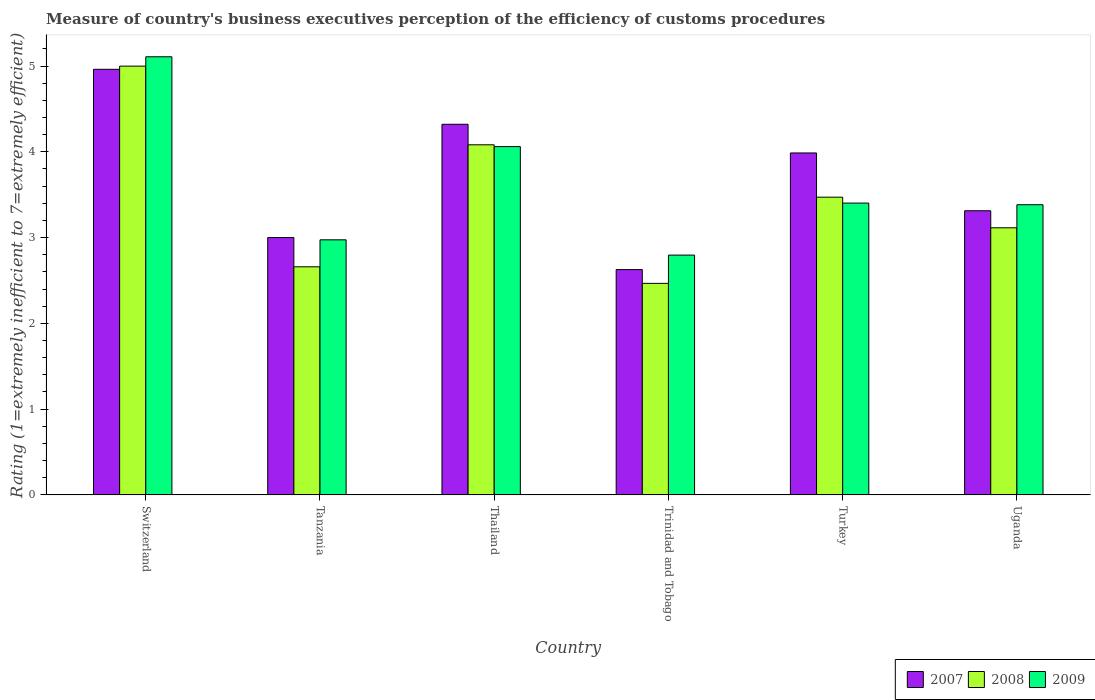Are the number of bars per tick equal to the number of legend labels?
Your response must be concise. Yes. How many bars are there on the 2nd tick from the left?
Provide a succinct answer. 3. How many bars are there on the 2nd tick from the right?
Keep it short and to the point. 3. What is the label of the 6th group of bars from the left?
Offer a very short reply. Uganda. In how many cases, is the number of bars for a given country not equal to the number of legend labels?
Provide a short and direct response. 0. What is the rating of the efficiency of customs procedure in 2009 in Turkey?
Offer a terse response. 3.4. Across all countries, what is the maximum rating of the efficiency of customs procedure in 2009?
Offer a terse response. 5.11. Across all countries, what is the minimum rating of the efficiency of customs procedure in 2008?
Make the answer very short. 2.47. In which country was the rating of the efficiency of customs procedure in 2007 maximum?
Your answer should be very brief. Switzerland. In which country was the rating of the efficiency of customs procedure in 2007 minimum?
Ensure brevity in your answer.  Trinidad and Tobago. What is the total rating of the efficiency of customs procedure in 2009 in the graph?
Ensure brevity in your answer.  21.72. What is the difference between the rating of the efficiency of customs procedure in 2009 in Tanzania and that in Trinidad and Tobago?
Offer a very short reply. 0.18. What is the difference between the rating of the efficiency of customs procedure in 2007 in Trinidad and Tobago and the rating of the efficiency of customs procedure in 2008 in Switzerland?
Your answer should be very brief. -2.37. What is the average rating of the efficiency of customs procedure in 2008 per country?
Your answer should be compact. 3.46. What is the difference between the rating of the efficiency of customs procedure of/in 2009 and rating of the efficiency of customs procedure of/in 2008 in Trinidad and Tobago?
Offer a very short reply. 0.33. In how many countries, is the rating of the efficiency of customs procedure in 2007 greater than 4.6?
Ensure brevity in your answer.  1. What is the ratio of the rating of the efficiency of customs procedure in 2007 in Trinidad and Tobago to that in Uganda?
Give a very brief answer. 0.79. Is the rating of the efficiency of customs procedure in 2007 in Switzerland less than that in Turkey?
Provide a short and direct response. No. Is the difference between the rating of the efficiency of customs procedure in 2009 in Tanzania and Turkey greater than the difference between the rating of the efficiency of customs procedure in 2008 in Tanzania and Turkey?
Provide a short and direct response. Yes. What is the difference between the highest and the second highest rating of the efficiency of customs procedure in 2008?
Your response must be concise. -1.53. What is the difference between the highest and the lowest rating of the efficiency of customs procedure in 2008?
Provide a succinct answer. 2.53. What does the 3rd bar from the left in Switzerland represents?
Ensure brevity in your answer.  2009. Is it the case that in every country, the sum of the rating of the efficiency of customs procedure in 2008 and rating of the efficiency of customs procedure in 2007 is greater than the rating of the efficiency of customs procedure in 2009?
Offer a terse response. Yes. How many bars are there?
Your answer should be very brief. 18. Are all the bars in the graph horizontal?
Make the answer very short. No. Does the graph contain any zero values?
Provide a short and direct response. No. Does the graph contain grids?
Provide a short and direct response. No. How many legend labels are there?
Make the answer very short. 3. What is the title of the graph?
Your answer should be compact. Measure of country's business executives perception of the efficiency of customs procedures. Does "2013" appear as one of the legend labels in the graph?
Make the answer very short. No. What is the label or title of the X-axis?
Provide a short and direct response. Country. What is the label or title of the Y-axis?
Provide a succinct answer. Rating (1=extremely inefficient to 7=extremely efficient). What is the Rating (1=extremely inefficient to 7=extremely efficient) in 2007 in Switzerland?
Offer a terse response. 4.96. What is the Rating (1=extremely inefficient to 7=extremely efficient) of 2008 in Switzerland?
Offer a terse response. 5. What is the Rating (1=extremely inefficient to 7=extremely efficient) in 2009 in Switzerland?
Offer a very short reply. 5.11. What is the Rating (1=extremely inefficient to 7=extremely efficient) in 2007 in Tanzania?
Provide a short and direct response. 3. What is the Rating (1=extremely inefficient to 7=extremely efficient) of 2008 in Tanzania?
Provide a succinct answer. 2.66. What is the Rating (1=extremely inefficient to 7=extremely efficient) in 2009 in Tanzania?
Make the answer very short. 2.97. What is the Rating (1=extremely inefficient to 7=extremely efficient) of 2007 in Thailand?
Provide a short and direct response. 4.32. What is the Rating (1=extremely inefficient to 7=extremely efficient) of 2008 in Thailand?
Ensure brevity in your answer.  4.08. What is the Rating (1=extremely inefficient to 7=extremely efficient) of 2009 in Thailand?
Ensure brevity in your answer.  4.06. What is the Rating (1=extremely inefficient to 7=extremely efficient) of 2007 in Trinidad and Tobago?
Your response must be concise. 2.63. What is the Rating (1=extremely inefficient to 7=extremely efficient) in 2008 in Trinidad and Tobago?
Make the answer very short. 2.47. What is the Rating (1=extremely inefficient to 7=extremely efficient) in 2009 in Trinidad and Tobago?
Offer a terse response. 2.8. What is the Rating (1=extremely inefficient to 7=extremely efficient) of 2007 in Turkey?
Give a very brief answer. 3.99. What is the Rating (1=extremely inefficient to 7=extremely efficient) in 2008 in Turkey?
Ensure brevity in your answer.  3.47. What is the Rating (1=extremely inefficient to 7=extremely efficient) in 2009 in Turkey?
Your answer should be compact. 3.4. What is the Rating (1=extremely inefficient to 7=extremely efficient) in 2007 in Uganda?
Provide a short and direct response. 3.31. What is the Rating (1=extremely inefficient to 7=extremely efficient) of 2008 in Uganda?
Provide a succinct answer. 3.11. What is the Rating (1=extremely inefficient to 7=extremely efficient) of 2009 in Uganda?
Your answer should be compact. 3.38. Across all countries, what is the maximum Rating (1=extremely inefficient to 7=extremely efficient) of 2007?
Offer a very short reply. 4.96. Across all countries, what is the maximum Rating (1=extremely inefficient to 7=extremely efficient) of 2008?
Provide a short and direct response. 5. Across all countries, what is the maximum Rating (1=extremely inefficient to 7=extremely efficient) of 2009?
Offer a very short reply. 5.11. Across all countries, what is the minimum Rating (1=extremely inefficient to 7=extremely efficient) of 2007?
Offer a terse response. 2.63. Across all countries, what is the minimum Rating (1=extremely inefficient to 7=extremely efficient) of 2008?
Offer a terse response. 2.47. Across all countries, what is the minimum Rating (1=extremely inefficient to 7=extremely efficient) of 2009?
Keep it short and to the point. 2.8. What is the total Rating (1=extremely inefficient to 7=extremely efficient) in 2007 in the graph?
Offer a terse response. 22.21. What is the total Rating (1=extremely inefficient to 7=extremely efficient) of 2008 in the graph?
Make the answer very short. 20.79. What is the total Rating (1=extremely inefficient to 7=extremely efficient) of 2009 in the graph?
Offer a terse response. 21.72. What is the difference between the Rating (1=extremely inefficient to 7=extremely efficient) of 2007 in Switzerland and that in Tanzania?
Offer a terse response. 1.96. What is the difference between the Rating (1=extremely inefficient to 7=extremely efficient) in 2008 in Switzerland and that in Tanzania?
Keep it short and to the point. 2.34. What is the difference between the Rating (1=extremely inefficient to 7=extremely efficient) in 2009 in Switzerland and that in Tanzania?
Provide a succinct answer. 2.13. What is the difference between the Rating (1=extremely inefficient to 7=extremely efficient) in 2007 in Switzerland and that in Thailand?
Give a very brief answer. 0.64. What is the difference between the Rating (1=extremely inefficient to 7=extremely efficient) of 2008 in Switzerland and that in Thailand?
Offer a very short reply. 0.92. What is the difference between the Rating (1=extremely inefficient to 7=extremely efficient) in 2009 in Switzerland and that in Thailand?
Offer a very short reply. 1.05. What is the difference between the Rating (1=extremely inefficient to 7=extremely efficient) in 2007 in Switzerland and that in Trinidad and Tobago?
Offer a terse response. 2.33. What is the difference between the Rating (1=extremely inefficient to 7=extremely efficient) of 2008 in Switzerland and that in Trinidad and Tobago?
Give a very brief answer. 2.53. What is the difference between the Rating (1=extremely inefficient to 7=extremely efficient) of 2009 in Switzerland and that in Trinidad and Tobago?
Offer a terse response. 2.31. What is the difference between the Rating (1=extremely inefficient to 7=extremely efficient) in 2007 in Switzerland and that in Turkey?
Provide a succinct answer. 0.98. What is the difference between the Rating (1=extremely inefficient to 7=extremely efficient) in 2008 in Switzerland and that in Turkey?
Offer a very short reply. 1.53. What is the difference between the Rating (1=extremely inefficient to 7=extremely efficient) of 2009 in Switzerland and that in Turkey?
Give a very brief answer. 1.71. What is the difference between the Rating (1=extremely inefficient to 7=extremely efficient) of 2007 in Switzerland and that in Uganda?
Offer a terse response. 1.65. What is the difference between the Rating (1=extremely inefficient to 7=extremely efficient) in 2008 in Switzerland and that in Uganda?
Your response must be concise. 1.88. What is the difference between the Rating (1=extremely inefficient to 7=extremely efficient) in 2009 in Switzerland and that in Uganda?
Your response must be concise. 1.72. What is the difference between the Rating (1=extremely inefficient to 7=extremely efficient) in 2007 in Tanzania and that in Thailand?
Offer a very short reply. -1.32. What is the difference between the Rating (1=extremely inefficient to 7=extremely efficient) in 2008 in Tanzania and that in Thailand?
Offer a very short reply. -1.42. What is the difference between the Rating (1=extremely inefficient to 7=extremely efficient) of 2009 in Tanzania and that in Thailand?
Your answer should be compact. -1.09. What is the difference between the Rating (1=extremely inefficient to 7=extremely efficient) of 2007 in Tanzania and that in Trinidad and Tobago?
Ensure brevity in your answer.  0.37. What is the difference between the Rating (1=extremely inefficient to 7=extremely efficient) in 2008 in Tanzania and that in Trinidad and Tobago?
Your response must be concise. 0.19. What is the difference between the Rating (1=extremely inefficient to 7=extremely efficient) in 2009 in Tanzania and that in Trinidad and Tobago?
Provide a succinct answer. 0.18. What is the difference between the Rating (1=extremely inefficient to 7=extremely efficient) in 2007 in Tanzania and that in Turkey?
Offer a terse response. -0.99. What is the difference between the Rating (1=extremely inefficient to 7=extremely efficient) of 2008 in Tanzania and that in Turkey?
Offer a very short reply. -0.81. What is the difference between the Rating (1=extremely inefficient to 7=extremely efficient) in 2009 in Tanzania and that in Turkey?
Offer a terse response. -0.43. What is the difference between the Rating (1=extremely inefficient to 7=extremely efficient) in 2007 in Tanzania and that in Uganda?
Provide a succinct answer. -0.31. What is the difference between the Rating (1=extremely inefficient to 7=extremely efficient) in 2008 in Tanzania and that in Uganda?
Your answer should be compact. -0.45. What is the difference between the Rating (1=extremely inefficient to 7=extremely efficient) of 2009 in Tanzania and that in Uganda?
Keep it short and to the point. -0.41. What is the difference between the Rating (1=extremely inefficient to 7=extremely efficient) of 2007 in Thailand and that in Trinidad and Tobago?
Ensure brevity in your answer.  1.69. What is the difference between the Rating (1=extremely inefficient to 7=extremely efficient) of 2008 in Thailand and that in Trinidad and Tobago?
Ensure brevity in your answer.  1.62. What is the difference between the Rating (1=extremely inefficient to 7=extremely efficient) of 2009 in Thailand and that in Trinidad and Tobago?
Offer a terse response. 1.26. What is the difference between the Rating (1=extremely inefficient to 7=extremely efficient) of 2007 in Thailand and that in Turkey?
Your answer should be very brief. 0.33. What is the difference between the Rating (1=extremely inefficient to 7=extremely efficient) in 2008 in Thailand and that in Turkey?
Ensure brevity in your answer.  0.61. What is the difference between the Rating (1=extremely inefficient to 7=extremely efficient) of 2009 in Thailand and that in Turkey?
Keep it short and to the point. 0.66. What is the difference between the Rating (1=extremely inefficient to 7=extremely efficient) of 2007 in Thailand and that in Uganda?
Your answer should be compact. 1.01. What is the difference between the Rating (1=extremely inefficient to 7=extremely efficient) of 2008 in Thailand and that in Uganda?
Keep it short and to the point. 0.97. What is the difference between the Rating (1=extremely inefficient to 7=extremely efficient) in 2009 in Thailand and that in Uganda?
Keep it short and to the point. 0.68. What is the difference between the Rating (1=extremely inefficient to 7=extremely efficient) of 2007 in Trinidad and Tobago and that in Turkey?
Offer a terse response. -1.36. What is the difference between the Rating (1=extremely inefficient to 7=extremely efficient) of 2008 in Trinidad and Tobago and that in Turkey?
Give a very brief answer. -1. What is the difference between the Rating (1=extremely inefficient to 7=extremely efficient) in 2009 in Trinidad and Tobago and that in Turkey?
Your response must be concise. -0.61. What is the difference between the Rating (1=extremely inefficient to 7=extremely efficient) of 2007 in Trinidad and Tobago and that in Uganda?
Your answer should be compact. -0.69. What is the difference between the Rating (1=extremely inefficient to 7=extremely efficient) in 2008 in Trinidad and Tobago and that in Uganda?
Keep it short and to the point. -0.65. What is the difference between the Rating (1=extremely inefficient to 7=extremely efficient) of 2009 in Trinidad and Tobago and that in Uganda?
Offer a terse response. -0.59. What is the difference between the Rating (1=extremely inefficient to 7=extremely efficient) of 2007 in Turkey and that in Uganda?
Offer a terse response. 0.67. What is the difference between the Rating (1=extremely inefficient to 7=extremely efficient) in 2008 in Turkey and that in Uganda?
Give a very brief answer. 0.36. What is the difference between the Rating (1=extremely inefficient to 7=extremely efficient) of 2009 in Turkey and that in Uganda?
Your response must be concise. 0.02. What is the difference between the Rating (1=extremely inefficient to 7=extremely efficient) of 2007 in Switzerland and the Rating (1=extremely inefficient to 7=extremely efficient) of 2008 in Tanzania?
Your response must be concise. 2.3. What is the difference between the Rating (1=extremely inefficient to 7=extremely efficient) in 2007 in Switzerland and the Rating (1=extremely inefficient to 7=extremely efficient) in 2009 in Tanzania?
Keep it short and to the point. 1.99. What is the difference between the Rating (1=extremely inefficient to 7=extremely efficient) of 2008 in Switzerland and the Rating (1=extremely inefficient to 7=extremely efficient) of 2009 in Tanzania?
Your answer should be very brief. 2.02. What is the difference between the Rating (1=extremely inefficient to 7=extremely efficient) of 2007 in Switzerland and the Rating (1=extremely inefficient to 7=extremely efficient) of 2008 in Thailand?
Your response must be concise. 0.88. What is the difference between the Rating (1=extremely inefficient to 7=extremely efficient) in 2007 in Switzerland and the Rating (1=extremely inefficient to 7=extremely efficient) in 2009 in Thailand?
Provide a succinct answer. 0.9. What is the difference between the Rating (1=extremely inefficient to 7=extremely efficient) in 2008 in Switzerland and the Rating (1=extremely inefficient to 7=extremely efficient) in 2009 in Thailand?
Your answer should be very brief. 0.94. What is the difference between the Rating (1=extremely inefficient to 7=extremely efficient) in 2007 in Switzerland and the Rating (1=extremely inefficient to 7=extremely efficient) in 2008 in Trinidad and Tobago?
Ensure brevity in your answer.  2.5. What is the difference between the Rating (1=extremely inefficient to 7=extremely efficient) in 2007 in Switzerland and the Rating (1=extremely inefficient to 7=extremely efficient) in 2009 in Trinidad and Tobago?
Your answer should be very brief. 2.17. What is the difference between the Rating (1=extremely inefficient to 7=extremely efficient) of 2008 in Switzerland and the Rating (1=extremely inefficient to 7=extremely efficient) of 2009 in Trinidad and Tobago?
Provide a short and direct response. 2.2. What is the difference between the Rating (1=extremely inefficient to 7=extremely efficient) of 2007 in Switzerland and the Rating (1=extremely inefficient to 7=extremely efficient) of 2008 in Turkey?
Provide a succinct answer. 1.49. What is the difference between the Rating (1=extremely inefficient to 7=extremely efficient) of 2007 in Switzerland and the Rating (1=extremely inefficient to 7=extremely efficient) of 2009 in Turkey?
Provide a short and direct response. 1.56. What is the difference between the Rating (1=extremely inefficient to 7=extremely efficient) of 2008 in Switzerland and the Rating (1=extremely inefficient to 7=extremely efficient) of 2009 in Turkey?
Offer a very short reply. 1.6. What is the difference between the Rating (1=extremely inefficient to 7=extremely efficient) of 2007 in Switzerland and the Rating (1=extremely inefficient to 7=extremely efficient) of 2008 in Uganda?
Your answer should be compact. 1.85. What is the difference between the Rating (1=extremely inefficient to 7=extremely efficient) in 2007 in Switzerland and the Rating (1=extremely inefficient to 7=extremely efficient) in 2009 in Uganda?
Make the answer very short. 1.58. What is the difference between the Rating (1=extremely inefficient to 7=extremely efficient) of 2008 in Switzerland and the Rating (1=extremely inefficient to 7=extremely efficient) of 2009 in Uganda?
Give a very brief answer. 1.62. What is the difference between the Rating (1=extremely inefficient to 7=extremely efficient) of 2007 in Tanzania and the Rating (1=extremely inefficient to 7=extremely efficient) of 2008 in Thailand?
Keep it short and to the point. -1.08. What is the difference between the Rating (1=extremely inefficient to 7=extremely efficient) in 2007 in Tanzania and the Rating (1=extremely inefficient to 7=extremely efficient) in 2009 in Thailand?
Your answer should be very brief. -1.06. What is the difference between the Rating (1=extremely inefficient to 7=extremely efficient) of 2008 in Tanzania and the Rating (1=extremely inefficient to 7=extremely efficient) of 2009 in Thailand?
Offer a very short reply. -1.4. What is the difference between the Rating (1=extremely inefficient to 7=extremely efficient) of 2007 in Tanzania and the Rating (1=extremely inefficient to 7=extremely efficient) of 2008 in Trinidad and Tobago?
Give a very brief answer. 0.53. What is the difference between the Rating (1=extremely inefficient to 7=extremely efficient) in 2007 in Tanzania and the Rating (1=extremely inefficient to 7=extremely efficient) in 2009 in Trinidad and Tobago?
Keep it short and to the point. 0.2. What is the difference between the Rating (1=extremely inefficient to 7=extremely efficient) of 2008 in Tanzania and the Rating (1=extremely inefficient to 7=extremely efficient) of 2009 in Trinidad and Tobago?
Your response must be concise. -0.14. What is the difference between the Rating (1=extremely inefficient to 7=extremely efficient) in 2007 in Tanzania and the Rating (1=extremely inefficient to 7=extremely efficient) in 2008 in Turkey?
Provide a short and direct response. -0.47. What is the difference between the Rating (1=extremely inefficient to 7=extremely efficient) in 2007 in Tanzania and the Rating (1=extremely inefficient to 7=extremely efficient) in 2009 in Turkey?
Offer a very short reply. -0.4. What is the difference between the Rating (1=extremely inefficient to 7=extremely efficient) in 2008 in Tanzania and the Rating (1=extremely inefficient to 7=extremely efficient) in 2009 in Turkey?
Ensure brevity in your answer.  -0.74. What is the difference between the Rating (1=extremely inefficient to 7=extremely efficient) of 2007 in Tanzania and the Rating (1=extremely inefficient to 7=extremely efficient) of 2008 in Uganda?
Provide a succinct answer. -0.11. What is the difference between the Rating (1=extremely inefficient to 7=extremely efficient) of 2007 in Tanzania and the Rating (1=extremely inefficient to 7=extremely efficient) of 2009 in Uganda?
Make the answer very short. -0.38. What is the difference between the Rating (1=extremely inefficient to 7=extremely efficient) in 2008 in Tanzania and the Rating (1=extremely inefficient to 7=extremely efficient) in 2009 in Uganda?
Your response must be concise. -0.72. What is the difference between the Rating (1=extremely inefficient to 7=extremely efficient) in 2007 in Thailand and the Rating (1=extremely inefficient to 7=extremely efficient) in 2008 in Trinidad and Tobago?
Offer a very short reply. 1.85. What is the difference between the Rating (1=extremely inefficient to 7=extremely efficient) of 2007 in Thailand and the Rating (1=extremely inefficient to 7=extremely efficient) of 2009 in Trinidad and Tobago?
Your answer should be very brief. 1.53. What is the difference between the Rating (1=extremely inefficient to 7=extremely efficient) in 2008 in Thailand and the Rating (1=extremely inefficient to 7=extremely efficient) in 2009 in Trinidad and Tobago?
Provide a succinct answer. 1.29. What is the difference between the Rating (1=extremely inefficient to 7=extremely efficient) in 2007 in Thailand and the Rating (1=extremely inefficient to 7=extremely efficient) in 2008 in Turkey?
Your answer should be very brief. 0.85. What is the difference between the Rating (1=extremely inefficient to 7=extremely efficient) of 2007 in Thailand and the Rating (1=extremely inefficient to 7=extremely efficient) of 2009 in Turkey?
Your answer should be very brief. 0.92. What is the difference between the Rating (1=extremely inefficient to 7=extremely efficient) of 2008 in Thailand and the Rating (1=extremely inefficient to 7=extremely efficient) of 2009 in Turkey?
Provide a short and direct response. 0.68. What is the difference between the Rating (1=extremely inefficient to 7=extremely efficient) of 2007 in Thailand and the Rating (1=extremely inefficient to 7=extremely efficient) of 2008 in Uganda?
Your response must be concise. 1.21. What is the difference between the Rating (1=extremely inefficient to 7=extremely efficient) in 2007 in Thailand and the Rating (1=extremely inefficient to 7=extremely efficient) in 2009 in Uganda?
Offer a very short reply. 0.94. What is the difference between the Rating (1=extremely inefficient to 7=extremely efficient) of 2008 in Thailand and the Rating (1=extremely inefficient to 7=extremely efficient) of 2009 in Uganda?
Offer a very short reply. 0.7. What is the difference between the Rating (1=extremely inefficient to 7=extremely efficient) in 2007 in Trinidad and Tobago and the Rating (1=extremely inefficient to 7=extremely efficient) in 2008 in Turkey?
Provide a succinct answer. -0.84. What is the difference between the Rating (1=extremely inefficient to 7=extremely efficient) of 2007 in Trinidad and Tobago and the Rating (1=extremely inefficient to 7=extremely efficient) of 2009 in Turkey?
Provide a succinct answer. -0.78. What is the difference between the Rating (1=extremely inefficient to 7=extremely efficient) in 2008 in Trinidad and Tobago and the Rating (1=extremely inefficient to 7=extremely efficient) in 2009 in Turkey?
Keep it short and to the point. -0.94. What is the difference between the Rating (1=extremely inefficient to 7=extremely efficient) of 2007 in Trinidad and Tobago and the Rating (1=extremely inefficient to 7=extremely efficient) of 2008 in Uganda?
Give a very brief answer. -0.49. What is the difference between the Rating (1=extremely inefficient to 7=extremely efficient) in 2007 in Trinidad and Tobago and the Rating (1=extremely inefficient to 7=extremely efficient) in 2009 in Uganda?
Give a very brief answer. -0.76. What is the difference between the Rating (1=extremely inefficient to 7=extremely efficient) in 2008 in Trinidad and Tobago and the Rating (1=extremely inefficient to 7=extremely efficient) in 2009 in Uganda?
Offer a very short reply. -0.92. What is the difference between the Rating (1=extremely inefficient to 7=extremely efficient) in 2007 in Turkey and the Rating (1=extremely inefficient to 7=extremely efficient) in 2008 in Uganda?
Your answer should be compact. 0.87. What is the difference between the Rating (1=extremely inefficient to 7=extremely efficient) in 2007 in Turkey and the Rating (1=extremely inefficient to 7=extremely efficient) in 2009 in Uganda?
Provide a short and direct response. 0.6. What is the difference between the Rating (1=extremely inefficient to 7=extremely efficient) of 2008 in Turkey and the Rating (1=extremely inefficient to 7=extremely efficient) of 2009 in Uganda?
Offer a very short reply. 0.09. What is the average Rating (1=extremely inefficient to 7=extremely efficient) in 2007 per country?
Make the answer very short. 3.7. What is the average Rating (1=extremely inefficient to 7=extremely efficient) of 2008 per country?
Your response must be concise. 3.46. What is the average Rating (1=extremely inefficient to 7=extremely efficient) of 2009 per country?
Keep it short and to the point. 3.62. What is the difference between the Rating (1=extremely inefficient to 7=extremely efficient) in 2007 and Rating (1=extremely inefficient to 7=extremely efficient) in 2008 in Switzerland?
Your answer should be very brief. -0.04. What is the difference between the Rating (1=extremely inefficient to 7=extremely efficient) of 2007 and Rating (1=extremely inefficient to 7=extremely efficient) of 2009 in Switzerland?
Provide a short and direct response. -0.15. What is the difference between the Rating (1=extremely inefficient to 7=extremely efficient) in 2008 and Rating (1=extremely inefficient to 7=extremely efficient) in 2009 in Switzerland?
Provide a short and direct response. -0.11. What is the difference between the Rating (1=extremely inefficient to 7=extremely efficient) of 2007 and Rating (1=extremely inefficient to 7=extremely efficient) of 2008 in Tanzania?
Provide a succinct answer. 0.34. What is the difference between the Rating (1=extremely inefficient to 7=extremely efficient) in 2007 and Rating (1=extremely inefficient to 7=extremely efficient) in 2009 in Tanzania?
Your response must be concise. 0.03. What is the difference between the Rating (1=extremely inefficient to 7=extremely efficient) in 2008 and Rating (1=extremely inefficient to 7=extremely efficient) in 2009 in Tanzania?
Your response must be concise. -0.31. What is the difference between the Rating (1=extremely inefficient to 7=extremely efficient) in 2007 and Rating (1=extremely inefficient to 7=extremely efficient) in 2008 in Thailand?
Offer a terse response. 0.24. What is the difference between the Rating (1=extremely inefficient to 7=extremely efficient) of 2007 and Rating (1=extremely inefficient to 7=extremely efficient) of 2009 in Thailand?
Your answer should be very brief. 0.26. What is the difference between the Rating (1=extremely inefficient to 7=extremely efficient) of 2008 and Rating (1=extremely inefficient to 7=extremely efficient) of 2009 in Thailand?
Provide a succinct answer. 0.02. What is the difference between the Rating (1=extremely inefficient to 7=extremely efficient) of 2007 and Rating (1=extremely inefficient to 7=extremely efficient) of 2008 in Trinidad and Tobago?
Ensure brevity in your answer.  0.16. What is the difference between the Rating (1=extremely inefficient to 7=extremely efficient) of 2007 and Rating (1=extremely inefficient to 7=extremely efficient) of 2009 in Trinidad and Tobago?
Give a very brief answer. -0.17. What is the difference between the Rating (1=extremely inefficient to 7=extremely efficient) of 2008 and Rating (1=extremely inefficient to 7=extremely efficient) of 2009 in Trinidad and Tobago?
Provide a succinct answer. -0.33. What is the difference between the Rating (1=extremely inefficient to 7=extremely efficient) in 2007 and Rating (1=extremely inefficient to 7=extremely efficient) in 2008 in Turkey?
Your answer should be very brief. 0.52. What is the difference between the Rating (1=extremely inefficient to 7=extremely efficient) in 2007 and Rating (1=extremely inefficient to 7=extremely efficient) in 2009 in Turkey?
Provide a short and direct response. 0.58. What is the difference between the Rating (1=extremely inefficient to 7=extremely efficient) in 2008 and Rating (1=extremely inefficient to 7=extremely efficient) in 2009 in Turkey?
Provide a succinct answer. 0.07. What is the difference between the Rating (1=extremely inefficient to 7=extremely efficient) of 2007 and Rating (1=extremely inefficient to 7=extremely efficient) of 2008 in Uganda?
Ensure brevity in your answer.  0.2. What is the difference between the Rating (1=extremely inefficient to 7=extremely efficient) in 2007 and Rating (1=extremely inefficient to 7=extremely efficient) in 2009 in Uganda?
Make the answer very short. -0.07. What is the difference between the Rating (1=extremely inefficient to 7=extremely efficient) of 2008 and Rating (1=extremely inefficient to 7=extremely efficient) of 2009 in Uganda?
Your answer should be very brief. -0.27. What is the ratio of the Rating (1=extremely inefficient to 7=extremely efficient) of 2007 in Switzerland to that in Tanzania?
Your response must be concise. 1.65. What is the ratio of the Rating (1=extremely inefficient to 7=extremely efficient) in 2008 in Switzerland to that in Tanzania?
Your answer should be compact. 1.88. What is the ratio of the Rating (1=extremely inefficient to 7=extremely efficient) of 2009 in Switzerland to that in Tanzania?
Make the answer very short. 1.72. What is the ratio of the Rating (1=extremely inefficient to 7=extremely efficient) in 2007 in Switzerland to that in Thailand?
Offer a terse response. 1.15. What is the ratio of the Rating (1=extremely inefficient to 7=extremely efficient) in 2008 in Switzerland to that in Thailand?
Offer a terse response. 1.22. What is the ratio of the Rating (1=extremely inefficient to 7=extremely efficient) in 2009 in Switzerland to that in Thailand?
Ensure brevity in your answer.  1.26. What is the ratio of the Rating (1=extremely inefficient to 7=extremely efficient) of 2007 in Switzerland to that in Trinidad and Tobago?
Provide a short and direct response. 1.89. What is the ratio of the Rating (1=extremely inefficient to 7=extremely efficient) of 2008 in Switzerland to that in Trinidad and Tobago?
Provide a succinct answer. 2.03. What is the ratio of the Rating (1=extremely inefficient to 7=extremely efficient) in 2009 in Switzerland to that in Trinidad and Tobago?
Ensure brevity in your answer.  1.83. What is the ratio of the Rating (1=extremely inefficient to 7=extremely efficient) in 2007 in Switzerland to that in Turkey?
Make the answer very short. 1.24. What is the ratio of the Rating (1=extremely inefficient to 7=extremely efficient) of 2008 in Switzerland to that in Turkey?
Your answer should be compact. 1.44. What is the ratio of the Rating (1=extremely inefficient to 7=extremely efficient) of 2009 in Switzerland to that in Turkey?
Your answer should be very brief. 1.5. What is the ratio of the Rating (1=extremely inefficient to 7=extremely efficient) in 2007 in Switzerland to that in Uganda?
Offer a terse response. 1.5. What is the ratio of the Rating (1=extremely inefficient to 7=extremely efficient) of 2008 in Switzerland to that in Uganda?
Offer a terse response. 1.61. What is the ratio of the Rating (1=extremely inefficient to 7=extremely efficient) in 2009 in Switzerland to that in Uganda?
Your response must be concise. 1.51. What is the ratio of the Rating (1=extremely inefficient to 7=extremely efficient) of 2007 in Tanzania to that in Thailand?
Keep it short and to the point. 0.69. What is the ratio of the Rating (1=extremely inefficient to 7=extremely efficient) in 2008 in Tanzania to that in Thailand?
Give a very brief answer. 0.65. What is the ratio of the Rating (1=extremely inefficient to 7=extremely efficient) of 2009 in Tanzania to that in Thailand?
Provide a succinct answer. 0.73. What is the ratio of the Rating (1=extremely inefficient to 7=extremely efficient) in 2007 in Tanzania to that in Trinidad and Tobago?
Your answer should be compact. 1.14. What is the ratio of the Rating (1=extremely inefficient to 7=extremely efficient) of 2008 in Tanzania to that in Trinidad and Tobago?
Ensure brevity in your answer.  1.08. What is the ratio of the Rating (1=extremely inefficient to 7=extremely efficient) of 2009 in Tanzania to that in Trinidad and Tobago?
Make the answer very short. 1.06. What is the ratio of the Rating (1=extremely inefficient to 7=extremely efficient) in 2007 in Tanzania to that in Turkey?
Ensure brevity in your answer.  0.75. What is the ratio of the Rating (1=extremely inefficient to 7=extremely efficient) in 2008 in Tanzania to that in Turkey?
Keep it short and to the point. 0.77. What is the ratio of the Rating (1=extremely inefficient to 7=extremely efficient) in 2009 in Tanzania to that in Turkey?
Provide a succinct answer. 0.87. What is the ratio of the Rating (1=extremely inefficient to 7=extremely efficient) in 2007 in Tanzania to that in Uganda?
Make the answer very short. 0.91. What is the ratio of the Rating (1=extremely inefficient to 7=extremely efficient) of 2008 in Tanzania to that in Uganda?
Keep it short and to the point. 0.85. What is the ratio of the Rating (1=extremely inefficient to 7=extremely efficient) of 2009 in Tanzania to that in Uganda?
Make the answer very short. 0.88. What is the ratio of the Rating (1=extremely inefficient to 7=extremely efficient) in 2007 in Thailand to that in Trinidad and Tobago?
Your answer should be very brief. 1.65. What is the ratio of the Rating (1=extremely inefficient to 7=extremely efficient) of 2008 in Thailand to that in Trinidad and Tobago?
Offer a very short reply. 1.66. What is the ratio of the Rating (1=extremely inefficient to 7=extremely efficient) in 2009 in Thailand to that in Trinidad and Tobago?
Your answer should be very brief. 1.45. What is the ratio of the Rating (1=extremely inefficient to 7=extremely efficient) of 2007 in Thailand to that in Turkey?
Make the answer very short. 1.08. What is the ratio of the Rating (1=extremely inefficient to 7=extremely efficient) in 2008 in Thailand to that in Turkey?
Provide a short and direct response. 1.18. What is the ratio of the Rating (1=extremely inefficient to 7=extremely efficient) of 2009 in Thailand to that in Turkey?
Your answer should be compact. 1.19. What is the ratio of the Rating (1=extremely inefficient to 7=extremely efficient) in 2007 in Thailand to that in Uganda?
Your answer should be very brief. 1.3. What is the ratio of the Rating (1=extremely inefficient to 7=extremely efficient) in 2008 in Thailand to that in Uganda?
Keep it short and to the point. 1.31. What is the ratio of the Rating (1=extremely inefficient to 7=extremely efficient) of 2009 in Thailand to that in Uganda?
Give a very brief answer. 1.2. What is the ratio of the Rating (1=extremely inefficient to 7=extremely efficient) of 2007 in Trinidad and Tobago to that in Turkey?
Offer a terse response. 0.66. What is the ratio of the Rating (1=extremely inefficient to 7=extremely efficient) in 2008 in Trinidad and Tobago to that in Turkey?
Make the answer very short. 0.71. What is the ratio of the Rating (1=extremely inefficient to 7=extremely efficient) of 2009 in Trinidad and Tobago to that in Turkey?
Give a very brief answer. 0.82. What is the ratio of the Rating (1=extremely inefficient to 7=extremely efficient) in 2007 in Trinidad and Tobago to that in Uganda?
Your answer should be compact. 0.79. What is the ratio of the Rating (1=extremely inefficient to 7=extremely efficient) in 2008 in Trinidad and Tobago to that in Uganda?
Make the answer very short. 0.79. What is the ratio of the Rating (1=extremely inefficient to 7=extremely efficient) of 2009 in Trinidad and Tobago to that in Uganda?
Your response must be concise. 0.83. What is the ratio of the Rating (1=extremely inefficient to 7=extremely efficient) of 2007 in Turkey to that in Uganda?
Make the answer very short. 1.2. What is the ratio of the Rating (1=extremely inefficient to 7=extremely efficient) of 2008 in Turkey to that in Uganda?
Give a very brief answer. 1.11. What is the difference between the highest and the second highest Rating (1=extremely inefficient to 7=extremely efficient) in 2007?
Keep it short and to the point. 0.64. What is the difference between the highest and the second highest Rating (1=extremely inefficient to 7=extremely efficient) in 2008?
Your response must be concise. 0.92. What is the difference between the highest and the second highest Rating (1=extremely inefficient to 7=extremely efficient) of 2009?
Make the answer very short. 1.05. What is the difference between the highest and the lowest Rating (1=extremely inefficient to 7=extremely efficient) of 2007?
Ensure brevity in your answer.  2.33. What is the difference between the highest and the lowest Rating (1=extremely inefficient to 7=extremely efficient) of 2008?
Provide a short and direct response. 2.53. What is the difference between the highest and the lowest Rating (1=extremely inefficient to 7=extremely efficient) of 2009?
Offer a terse response. 2.31. 